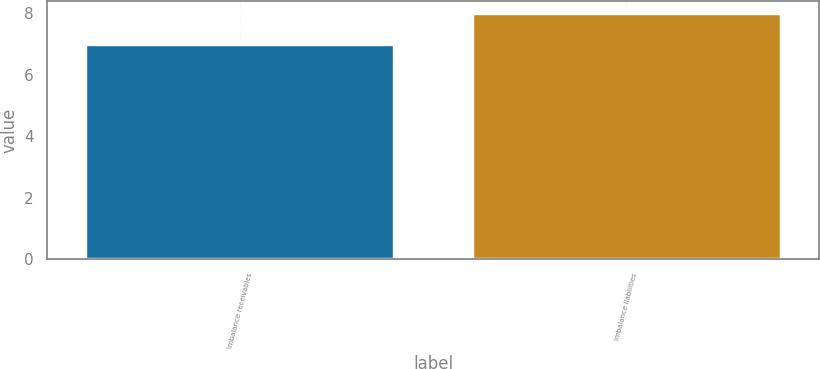<chart> <loc_0><loc_0><loc_500><loc_500><bar_chart><fcel>Imbalance receivables<fcel>Imbalance liabilities<nl><fcel>7<fcel>8<nl></chart> 